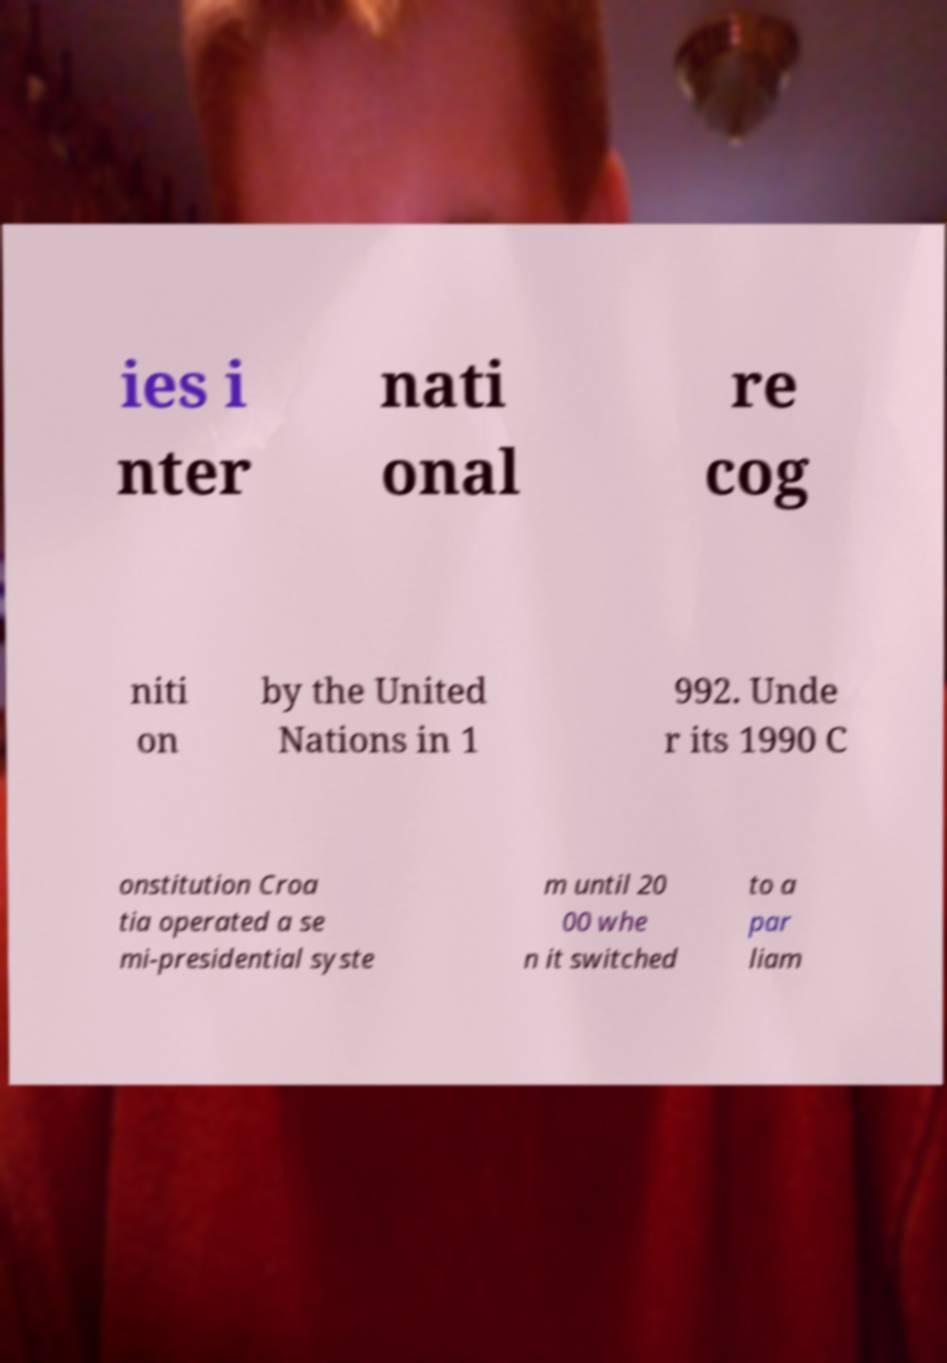Could you extract and type out the text from this image? ies i nter nati onal re cog niti on by the United Nations in 1 992. Unde r its 1990 C onstitution Croa tia operated a se mi-presidential syste m until 20 00 whe n it switched to a par liam 